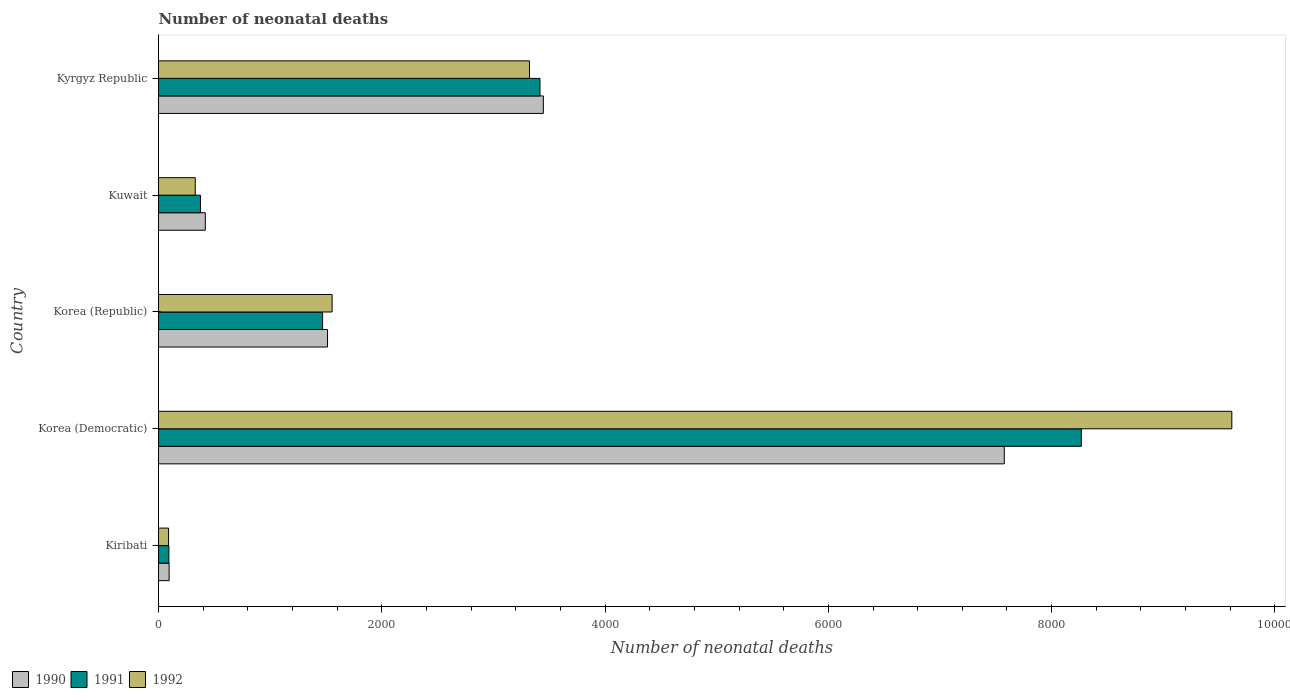How many groups of bars are there?
Your response must be concise. 5. Are the number of bars per tick equal to the number of legend labels?
Offer a terse response. Yes. How many bars are there on the 5th tick from the top?
Offer a terse response. 3. How many bars are there on the 3rd tick from the bottom?
Your answer should be compact. 3. What is the label of the 3rd group of bars from the top?
Offer a very short reply. Korea (Republic). In how many cases, is the number of bars for a given country not equal to the number of legend labels?
Keep it short and to the point. 0. What is the number of neonatal deaths in in 1990 in Kiribati?
Offer a terse response. 95. Across all countries, what is the maximum number of neonatal deaths in in 1992?
Your response must be concise. 9614. Across all countries, what is the minimum number of neonatal deaths in in 1990?
Offer a very short reply. 95. In which country was the number of neonatal deaths in in 1990 maximum?
Offer a very short reply. Korea (Democratic). In which country was the number of neonatal deaths in in 1992 minimum?
Your response must be concise. Kiribati. What is the total number of neonatal deaths in in 1991 in the graph?
Provide a short and direct response. 1.36e+04. What is the difference between the number of neonatal deaths in in 1990 in Kiribati and that in Korea (Democratic)?
Keep it short and to the point. -7481. What is the difference between the number of neonatal deaths in in 1992 in Kuwait and the number of neonatal deaths in in 1990 in Kyrgyz Republic?
Your answer should be very brief. -3118. What is the average number of neonatal deaths in in 1992 per country?
Provide a short and direct response. 2982.2. What is the difference between the number of neonatal deaths in in 1990 and number of neonatal deaths in in 1992 in Kiribati?
Provide a short and direct response. 5. In how many countries, is the number of neonatal deaths in in 1990 greater than 1200 ?
Make the answer very short. 3. What is the ratio of the number of neonatal deaths in in 1991 in Korea (Democratic) to that in Kyrgyz Republic?
Ensure brevity in your answer.  2.42. Is the number of neonatal deaths in in 1992 in Kiribati less than that in Korea (Republic)?
Provide a short and direct response. Yes. What is the difference between the highest and the second highest number of neonatal deaths in in 1990?
Your answer should be compact. 4129. What is the difference between the highest and the lowest number of neonatal deaths in in 1990?
Provide a short and direct response. 7481. Is the sum of the number of neonatal deaths in in 1990 in Korea (Republic) and Kuwait greater than the maximum number of neonatal deaths in in 1991 across all countries?
Your answer should be compact. No. Is it the case that in every country, the sum of the number of neonatal deaths in in 1991 and number of neonatal deaths in in 1992 is greater than the number of neonatal deaths in in 1990?
Your answer should be very brief. Yes. How many bars are there?
Your answer should be compact. 15. Are all the bars in the graph horizontal?
Your answer should be very brief. Yes. How many countries are there in the graph?
Your response must be concise. 5. Are the values on the major ticks of X-axis written in scientific E-notation?
Your answer should be very brief. No. Does the graph contain any zero values?
Ensure brevity in your answer.  No. Does the graph contain grids?
Give a very brief answer. No. Where does the legend appear in the graph?
Provide a succinct answer. Bottom left. How many legend labels are there?
Keep it short and to the point. 3. How are the legend labels stacked?
Offer a very short reply. Horizontal. What is the title of the graph?
Offer a terse response. Number of neonatal deaths. What is the label or title of the X-axis?
Your response must be concise. Number of neonatal deaths. What is the label or title of the Y-axis?
Provide a short and direct response. Country. What is the Number of neonatal deaths in 1991 in Kiribati?
Keep it short and to the point. 93. What is the Number of neonatal deaths in 1990 in Korea (Democratic)?
Ensure brevity in your answer.  7576. What is the Number of neonatal deaths of 1991 in Korea (Democratic)?
Offer a very short reply. 8266. What is the Number of neonatal deaths of 1992 in Korea (Democratic)?
Offer a very short reply. 9614. What is the Number of neonatal deaths in 1990 in Korea (Republic)?
Offer a terse response. 1514. What is the Number of neonatal deaths in 1991 in Korea (Republic)?
Offer a very short reply. 1470. What is the Number of neonatal deaths of 1992 in Korea (Republic)?
Ensure brevity in your answer.  1555. What is the Number of neonatal deaths of 1990 in Kuwait?
Ensure brevity in your answer.  419. What is the Number of neonatal deaths in 1991 in Kuwait?
Your answer should be compact. 376. What is the Number of neonatal deaths of 1992 in Kuwait?
Offer a very short reply. 329. What is the Number of neonatal deaths of 1990 in Kyrgyz Republic?
Make the answer very short. 3447. What is the Number of neonatal deaths of 1991 in Kyrgyz Republic?
Make the answer very short. 3417. What is the Number of neonatal deaths in 1992 in Kyrgyz Republic?
Your answer should be very brief. 3323. Across all countries, what is the maximum Number of neonatal deaths in 1990?
Provide a short and direct response. 7576. Across all countries, what is the maximum Number of neonatal deaths in 1991?
Give a very brief answer. 8266. Across all countries, what is the maximum Number of neonatal deaths in 1992?
Your response must be concise. 9614. Across all countries, what is the minimum Number of neonatal deaths in 1991?
Offer a terse response. 93. What is the total Number of neonatal deaths in 1990 in the graph?
Your answer should be very brief. 1.31e+04. What is the total Number of neonatal deaths in 1991 in the graph?
Your answer should be compact. 1.36e+04. What is the total Number of neonatal deaths of 1992 in the graph?
Make the answer very short. 1.49e+04. What is the difference between the Number of neonatal deaths of 1990 in Kiribati and that in Korea (Democratic)?
Make the answer very short. -7481. What is the difference between the Number of neonatal deaths in 1991 in Kiribati and that in Korea (Democratic)?
Provide a short and direct response. -8173. What is the difference between the Number of neonatal deaths in 1992 in Kiribati and that in Korea (Democratic)?
Your answer should be compact. -9524. What is the difference between the Number of neonatal deaths in 1990 in Kiribati and that in Korea (Republic)?
Make the answer very short. -1419. What is the difference between the Number of neonatal deaths in 1991 in Kiribati and that in Korea (Republic)?
Offer a very short reply. -1377. What is the difference between the Number of neonatal deaths in 1992 in Kiribati and that in Korea (Republic)?
Offer a terse response. -1465. What is the difference between the Number of neonatal deaths of 1990 in Kiribati and that in Kuwait?
Give a very brief answer. -324. What is the difference between the Number of neonatal deaths in 1991 in Kiribati and that in Kuwait?
Make the answer very short. -283. What is the difference between the Number of neonatal deaths of 1992 in Kiribati and that in Kuwait?
Offer a terse response. -239. What is the difference between the Number of neonatal deaths of 1990 in Kiribati and that in Kyrgyz Republic?
Offer a terse response. -3352. What is the difference between the Number of neonatal deaths of 1991 in Kiribati and that in Kyrgyz Republic?
Offer a terse response. -3324. What is the difference between the Number of neonatal deaths of 1992 in Kiribati and that in Kyrgyz Republic?
Make the answer very short. -3233. What is the difference between the Number of neonatal deaths of 1990 in Korea (Democratic) and that in Korea (Republic)?
Provide a succinct answer. 6062. What is the difference between the Number of neonatal deaths of 1991 in Korea (Democratic) and that in Korea (Republic)?
Your answer should be very brief. 6796. What is the difference between the Number of neonatal deaths of 1992 in Korea (Democratic) and that in Korea (Republic)?
Make the answer very short. 8059. What is the difference between the Number of neonatal deaths in 1990 in Korea (Democratic) and that in Kuwait?
Provide a short and direct response. 7157. What is the difference between the Number of neonatal deaths in 1991 in Korea (Democratic) and that in Kuwait?
Make the answer very short. 7890. What is the difference between the Number of neonatal deaths in 1992 in Korea (Democratic) and that in Kuwait?
Your response must be concise. 9285. What is the difference between the Number of neonatal deaths in 1990 in Korea (Democratic) and that in Kyrgyz Republic?
Ensure brevity in your answer.  4129. What is the difference between the Number of neonatal deaths in 1991 in Korea (Democratic) and that in Kyrgyz Republic?
Your answer should be very brief. 4849. What is the difference between the Number of neonatal deaths in 1992 in Korea (Democratic) and that in Kyrgyz Republic?
Make the answer very short. 6291. What is the difference between the Number of neonatal deaths in 1990 in Korea (Republic) and that in Kuwait?
Ensure brevity in your answer.  1095. What is the difference between the Number of neonatal deaths of 1991 in Korea (Republic) and that in Kuwait?
Keep it short and to the point. 1094. What is the difference between the Number of neonatal deaths in 1992 in Korea (Republic) and that in Kuwait?
Ensure brevity in your answer.  1226. What is the difference between the Number of neonatal deaths in 1990 in Korea (Republic) and that in Kyrgyz Republic?
Provide a succinct answer. -1933. What is the difference between the Number of neonatal deaths of 1991 in Korea (Republic) and that in Kyrgyz Republic?
Provide a short and direct response. -1947. What is the difference between the Number of neonatal deaths in 1992 in Korea (Republic) and that in Kyrgyz Republic?
Keep it short and to the point. -1768. What is the difference between the Number of neonatal deaths of 1990 in Kuwait and that in Kyrgyz Republic?
Make the answer very short. -3028. What is the difference between the Number of neonatal deaths in 1991 in Kuwait and that in Kyrgyz Republic?
Offer a terse response. -3041. What is the difference between the Number of neonatal deaths in 1992 in Kuwait and that in Kyrgyz Republic?
Your response must be concise. -2994. What is the difference between the Number of neonatal deaths of 1990 in Kiribati and the Number of neonatal deaths of 1991 in Korea (Democratic)?
Give a very brief answer. -8171. What is the difference between the Number of neonatal deaths in 1990 in Kiribati and the Number of neonatal deaths in 1992 in Korea (Democratic)?
Keep it short and to the point. -9519. What is the difference between the Number of neonatal deaths of 1991 in Kiribati and the Number of neonatal deaths of 1992 in Korea (Democratic)?
Your answer should be compact. -9521. What is the difference between the Number of neonatal deaths of 1990 in Kiribati and the Number of neonatal deaths of 1991 in Korea (Republic)?
Your answer should be compact. -1375. What is the difference between the Number of neonatal deaths in 1990 in Kiribati and the Number of neonatal deaths in 1992 in Korea (Republic)?
Provide a succinct answer. -1460. What is the difference between the Number of neonatal deaths of 1991 in Kiribati and the Number of neonatal deaths of 1992 in Korea (Republic)?
Offer a terse response. -1462. What is the difference between the Number of neonatal deaths of 1990 in Kiribati and the Number of neonatal deaths of 1991 in Kuwait?
Provide a short and direct response. -281. What is the difference between the Number of neonatal deaths of 1990 in Kiribati and the Number of neonatal deaths of 1992 in Kuwait?
Give a very brief answer. -234. What is the difference between the Number of neonatal deaths in 1991 in Kiribati and the Number of neonatal deaths in 1992 in Kuwait?
Make the answer very short. -236. What is the difference between the Number of neonatal deaths of 1990 in Kiribati and the Number of neonatal deaths of 1991 in Kyrgyz Republic?
Provide a short and direct response. -3322. What is the difference between the Number of neonatal deaths in 1990 in Kiribati and the Number of neonatal deaths in 1992 in Kyrgyz Republic?
Keep it short and to the point. -3228. What is the difference between the Number of neonatal deaths in 1991 in Kiribati and the Number of neonatal deaths in 1992 in Kyrgyz Republic?
Your response must be concise. -3230. What is the difference between the Number of neonatal deaths of 1990 in Korea (Democratic) and the Number of neonatal deaths of 1991 in Korea (Republic)?
Keep it short and to the point. 6106. What is the difference between the Number of neonatal deaths in 1990 in Korea (Democratic) and the Number of neonatal deaths in 1992 in Korea (Republic)?
Offer a very short reply. 6021. What is the difference between the Number of neonatal deaths of 1991 in Korea (Democratic) and the Number of neonatal deaths of 1992 in Korea (Republic)?
Your answer should be compact. 6711. What is the difference between the Number of neonatal deaths of 1990 in Korea (Democratic) and the Number of neonatal deaths of 1991 in Kuwait?
Keep it short and to the point. 7200. What is the difference between the Number of neonatal deaths in 1990 in Korea (Democratic) and the Number of neonatal deaths in 1992 in Kuwait?
Your answer should be very brief. 7247. What is the difference between the Number of neonatal deaths in 1991 in Korea (Democratic) and the Number of neonatal deaths in 1992 in Kuwait?
Offer a terse response. 7937. What is the difference between the Number of neonatal deaths of 1990 in Korea (Democratic) and the Number of neonatal deaths of 1991 in Kyrgyz Republic?
Your answer should be very brief. 4159. What is the difference between the Number of neonatal deaths of 1990 in Korea (Democratic) and the Number of neonatal deaths of 1992 in Kyrgyz Republic?
Keep it short and to the point. 4253. What is the difference between the Number of neonatal deaths in 1991 in Korea (Democratic) and the Number of neonatal deaths in 1992 in Kyrgyz Republic?
Provide a short and direct response. 4943. What is the difference between the Number of neonatal deaths in 1990 in Korea (Republic) and the Number of neonatal deaths in 1991 in Kuwait?
Provide a short and direct response. 1138. What is the difference between the Number of neonatal deaths of 1990 in Korea (Republic) and the Number of neonatal deaths of 1992 in Kuwait?
Offer a terse response. 1185. What is the difference between the Number of neonatal deaths in 1991 in Korea (Republic) and the Number of neonatal deaths in 1992 in Kuwait?
Your response must be concise. 1141. What is the difference between the Number of neonatal deaths in 1990 in Korea (Republic) and the Number of neonatal deaths in 1991 in Kyrgyz Republic?
Your response must be concise. -1903. What is the difference between the Number of neonatal deaths in 1990 in Korea (Republic) and the Number of neonatal deaths in 1992 in Kyrgyz Republic?
Offer a very short reply. -1809. What is the difference between the Number of neonatal deaths in 1991 in Korea (Republic) and the Number of neonatal deaths in 1992 in Kyrgyz Republic?
Your response must be concise. -1853. What is the difference between the Number of neonatal deaths of 1990 in Kuwait and the Number of neonatal deaths of 1991 in Kyrgyz Republic?
Offer a very short reply. -2998. What is the difference between the Number of neonatal deaths in 1990 in Kuwait and the Number of neonatal deaths in 1992 in Kyrgyz Republic?
Your answer should be compact. -2904. What is the difference between the Number of neonatal deaths of 1991 in Kuwait and the Number of neonatal deaths of 1992 in Kyrgyz Republic?
Your answer should be compact. -2947. What is the average Number of neonatal deaths in 1990 per country?
Your response must be concise. 2610.2. What is the average Number of neonatal deaths in 1991 per country?
Keep it short and to the point. 2724.4. What is the average Number of neonatal deaths in 1992 per country?
Offer a terse response. 2982.2. What is the difference between the Number of neonatal deaths in 1990 and Number of neonatal deaths in 1991 in Kiribati?
Offer a very short reply. 2. What is the difference between the Number of neonatal deaths in 1990 and Number of neonatal deaths in 1991 in Korea (Democratic)?
Keep it short and to the point. -690. What is the difference between the Number of neonatal deaths in 1990 and Number of neonatal deaths in 1992 in Korea (Democratic)?
Ensure brevity in your answer.  -2038. What is the difference between the Number of neonatal deaths of 1991 and Number of neonatal deaths of 1992 in Korea (Democratic)?
Provide a short and direct response. -1348. What is the difference between the Number of neonatal deaths of 1990 and Number of neonatal deaths of 1992 in Korea (Republic)?
Make the answer very short. -41. What is the difference between the Number of neonatal deaths in 1991 and Number of neonatal deaths in 1992 in Korea (Republic)?
Provide a succinct answer. -85. What is the difference between the Number of neonatal deaths in 1991 and Number of neonatal deaths in 1992 in Kuwait?
Provide a succinct answer. 47. What is the difference between the Number of neonatal deaths of 1990 and Number of neonatal deaths of 1992 in Kyrgyz Republic?
Your response must be concise. 124. What is the difference between the Number of neonatal deaths in 1991 and Number of neonatal deaths in 1992 in Kyrgyz Republic?
Your response must be concise. 94. What is the ratio of the Number of neonatal deaths in 1990 in Kiribati to that in Korea (Democratic)?
Your answer should be compact. 0.01. What is the ratio of the Number of neonatal deaths of 1991 in Kiribati to that in Korea (Democratic)?
Give a very brief answer. 0.01. What is the ratio of the Number of neonatal deaths of 1992 in Kiribati to that in Korea (Democratic)?
Your answer should be compact. 0.01. What is the ratio of the Number of neonatal deaths in 1990 in Kiribati to that in Korea (Republic)?
Your answer should be compact. 0.06. What is the ratio of the Number of neonatal deaths of 1991 in Kiribati to that in Korea (Republic)?
Provide a succinct answer. 0.06. What is the ratio of the Number of neonatal deaths of 1992 in Kiribati to that in Korea (Republic)?
Give a very brief answer. 0.06. What is the ratio of the Number of neonatal deaths of 1990 in Kiribati to that in Kuwait?
Make the answer very short. 0.23. What is the ratio of the Number of neonatal deaths in 1991 in Kiribati to that in Kuwait?
Offer a very short reply. 0.25. What is the ratio of the Number of neonatal deaths in 1992 in Kiribati to that in Kuwait?
Keep it short and to the point. 0.27. What is the ratio of the Number of neonatal deaths in 1990 in Kiribati to that in Kyrgyz Republic?
Give a very brief answer. 0.03. What is the ratio of the Number of neonatal deaths in 1991 in Kiribati to that in Kyrgyz Republic?
Provide a succinct answer. 0.03. What is the ratio of the Number of neonatal deaths in 1992 in Kiribati to that in Kyrgyz Republic?
Your response must be concise. 0.03. What is the ratio of the Number of neonatal deaths of 1990 in Korea (Democratic) to that in Korea (Republic)?
Your response must be concise. 5. What is the ratio of the Number of neonatal deaths of 1991 in Korea (Democratic) to that in Korea (Republic)?
Your answer should be compact. 5.62. What is the ratio of the Number of neonatal deaths of 1992 in Korea (Democratic) to that in Korea (Republic)?
Make the answer very short. 6.18. What is the ratio of the Number of neonatal deaths in 1990 in Korea (Democratic) to that in Kuwait?
Keep it short and to the point. 18.08. What is the ratio of the Number of neonatal deaths of 1991 in Korea (Democratic) to that in Kuwait?
Keep it short and to the point. 21.98. What is the ratio of the Number of neonatal deaths in 1992 in Korea (Democratic) to that in Kuwait?
Your response must be concise. 29.22. What is the ratio of the Number of neonatal deaths of 1990 in Korea (Democratic) to that in Kyrgyz Republic?
Give a very brief answer. 2.2. What is the ratio of the Number of neonatal deaths in 1991 in Korea (Democratic) to that in Kyrgyz Republic?
Provide a succinct answer. 2.42. What is the ratio of the Number of neonatal deaths in 1992 in Korea (Democratic) to that in Kyrgyz Republic?
Keep it short and to the point. 2.89. What is the ratio of the Number of neonatal deaths of 1990 in Korea (Republic) to that in Kuwait?
Offer a very short reply. 3.61. What is the ratio of the Number of neonatal deaths in 1991 in Korea (Republic) to that in Kuwait?
Your answer should be compact. 3.91. What is the ratio of the Number of neonatal deaths of 1992 in Korea (Republic) to that in Kuwait?
Ensure brevity in your answer.  4.73. What is the ratio of the Number of neonatal deaths of 1990 in Korea (Republic) to that in Kyrgyz Republic?
Offer a very short reply. 0.44. What is the ratio of the Number of neonatal deaths in 1991 in Korea (Republic) to that in Kyrgyz Republic?
Make the answer very short. 0.43. What is the ratio of the Number of neonatal deaths of 1992 in Korea (Republic) to that in Kyrgyz Republic?
Give a very brief answer. 0.47. What is the ratio of the Number of neonatal deaths of 1990 in Kuwait to that in Kyrgyz Republic?
Offer a terse response. 0.12. What is the ratio of the Number of neonatal deaths in 1991 in Kuwait to that in Kyrgyz Republic?
Make the answer very short. 0.11. What is the ratio of the Number of neonatal deaths in 1992 in Kuwait to that in Kyrgyz Republic?
Provide a short and direct response. 0.1. What is the difference between the highest and the second highest Number of neonatal deaths in 1990?
Make the answer very short. 4129. What is the difference between the highest and the second highest Number of neonatal deaths of 1991?
Your answer should be compact. 4849. What is the difference between the highest and the second highest Number of neonatal deaths in 1992?
Give a very brief answer. 6291. What is the difference between the highest and the lowest Number of neonatal deaths of 1990?
Ensure brevity in your answer.  7481. What is the difference between the highest and the lowest Number of neonatal deaths in 1991?
Your answer should be compact. 8173. What is the difference between the highest and the lowest Number of neonatal deaths of 1992?
Offer a very short reply. 9524. 